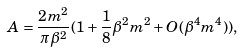<formula> <loc_0><loc_0><loc_500><loc_500>A = \frac { 2 m ^ { 2 } } { \pi \beta ^ { 2 } } ( 1 + \frac { 1 } { 8 } \beta ^ { 2 } m ^ { 2 } + O ( \beta ^ { 4 } m ^ { 4 } ) ) ,</formula> 